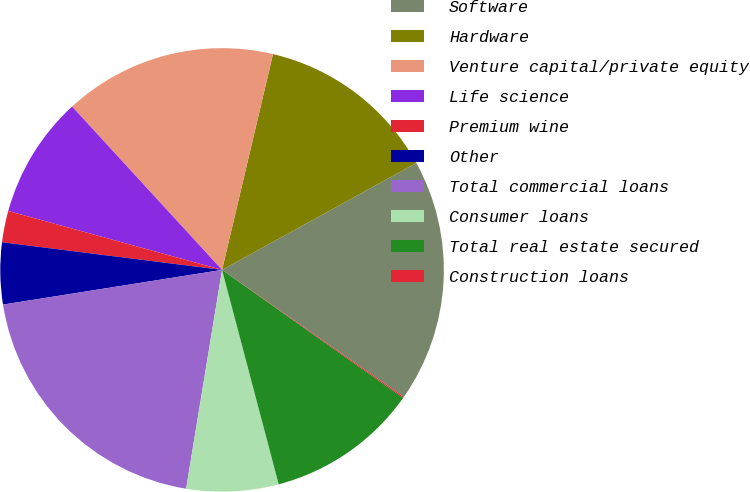<chart> <loc_0><loc_0><loc_500><loc_500><pie_chart><fcel>Software<fcel>Hardware<fcel>Venture capital/private equity<fcel>Life science<fcel>Premium wine<fcel>Other<fcel>Total commercial loans<fcel>Consumer loans<fcel>Total real estate secured<fcel>Construction loans<nl><fcel>17.71%<fcel>13.3%<fcel>15.51%<fcel>8.9%<fcel>2.29%<fcel>4.49%<fcel>19.91%<fcel>6.7%<fcel>11.1%<fcel>0.09%<nl></chart> 